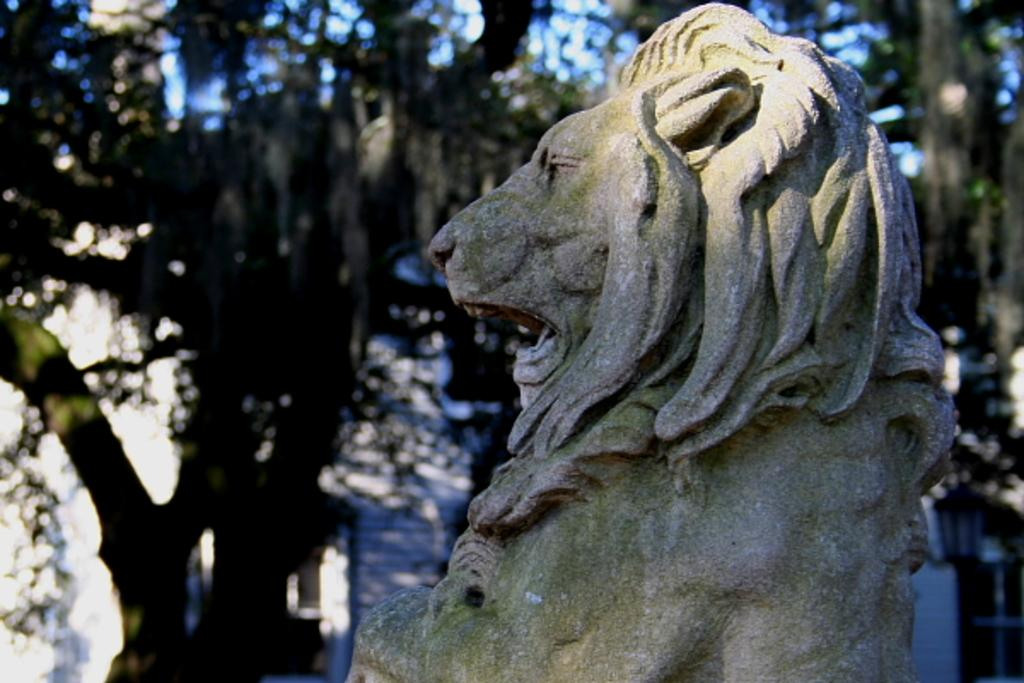What is the main subject in the foreground of the picture? There is a sculpture of a lion in the foreground of the picture. What can be seen in the background of the picture? There are trees in the background of the picture. How would you describe the weather in the image? The sky is sunny, which suggests a clear and bright day. What type of furniture is visible in the picture? There is no furniture present in the image; it features a sculpture of a lion and trees in the background. What reward can be seen being given to the lion in the picture? There is no reward being given to the lion in the picture; it is a sculpture and not a living creature. 